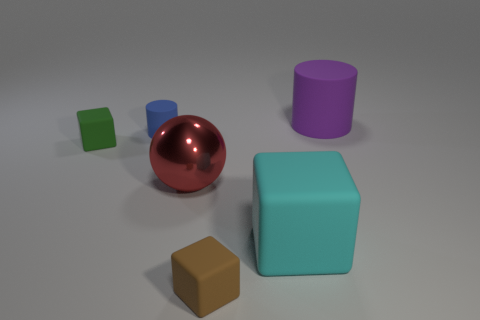Add 4 large purple rubber objects. How many objects exist? 10 Subtract all cylinders. How many objects are left? 4 Subtract all large cylinders. Subtract all small blue cylinders. How many objects are left? 4 Add 1 large purple things. How many large purple things are left? 2 Add 2 small cubes. How many small cubes exist? 4 Subtract 0 brown balls. How many objects are left? 6 